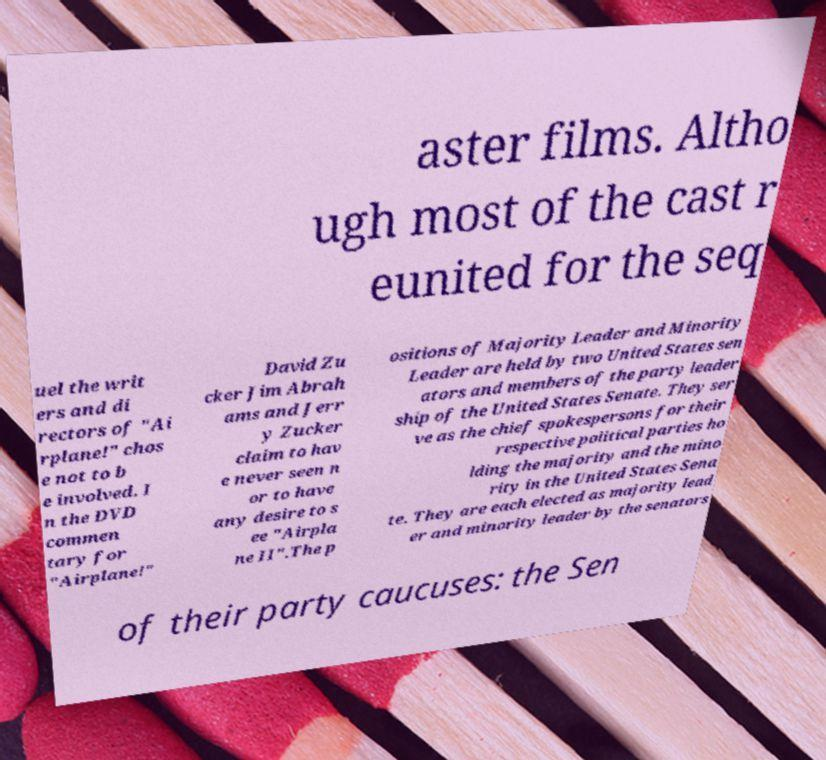Could you assist in decoding the text presented in this image and type it out clearly? aster films. Altho ugh most of the cast r eunited for the seq uel the writ ers and di rectors of "Ai rplane!" chos e not to b e involved. I n the DVD commen tary for "Airplane!" David Zu cker Jim Abrah ams and Jerr y Zucker claim to hav e never seen n or to have any desire to s ee "Airpla ne II".The p ositions of Majority Leader and Minority Leader are held by two United States sen ators and members of the party leader ship of the United States Senate. They ser ve as the chief spokespersons for their respective political parties ho lding the majority and the mino rity in the United States Sena te. They are each elected as majority lead er and minority leader by the senators of their party caucuses: the Sen 